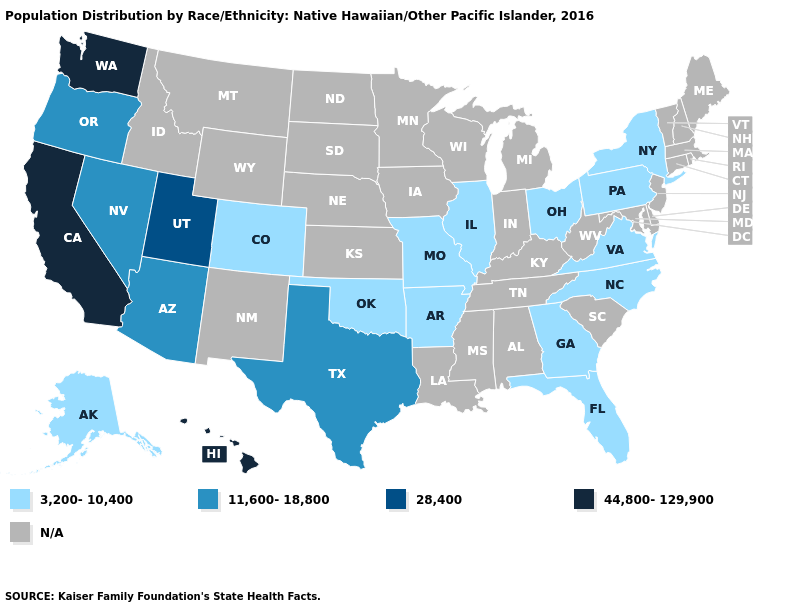What is the value of Rhode Island?
Concise answer only. N/A. What is the lowest value in the South?
Concise answer only. 3,200-10,400. Does the first symbol in the legend represent the smallest category?
Give a very brief answer. Yes. What is the value of Alabama?
Answer briefly. N/A. What is the value of Colorado?
Short answer required. 3,200-10,400. Among the states that border Connecticut , which have the lowest value?
Keep it brief. New York. Does Texas have the lowest value in the South?
Be succinct. No. What is the value of New Jersey?
Quick response, please. N/A. Does the first symbol in the legend represent the smallest category?
Concise answer only. Yes. Does Hawaii have the highest value in the USA?
Quick response, please. Yes. What is the lowest value in the USA?
Concise answer only. 3,200-10,400. What is the value of Kentucky?
Be succinct. N/A. Does the map have missing data?
Keep it brief. Yes. What is the value of Oregon?
Answer briefly. 11,600-18,800. Does Arkansas have the highest value in the USA?
Quick response, please. No. 